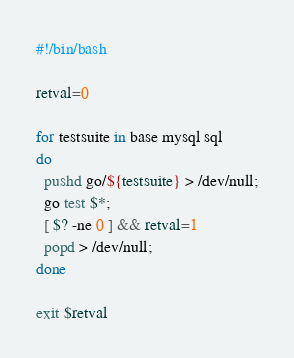Convert code to text. <code><loc_0><loc_0><loc_500><loc_500><_Bash_>#!/bin/bash

retval=0

for testsuite in base mysql sql
do
  pushd go/${testsuite} > /dev/null;
  go test $*;
  [ $? -ne 0 ] && retval=1
  popd > /dev/null;
done

exit $retval
</code> 